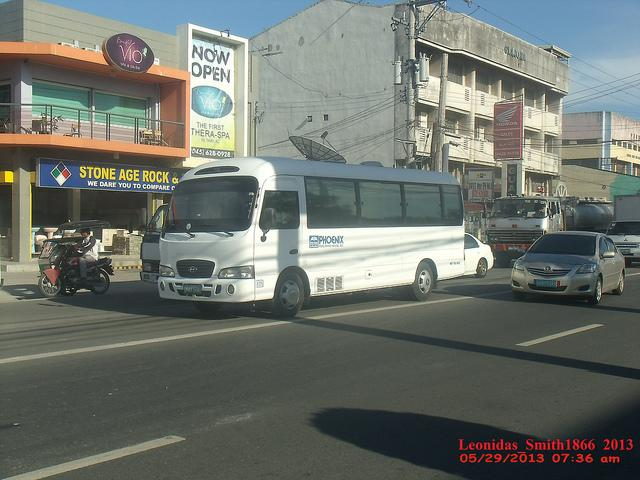What type of vehicle is sold in the building to the rear of the bus? motorcycles 